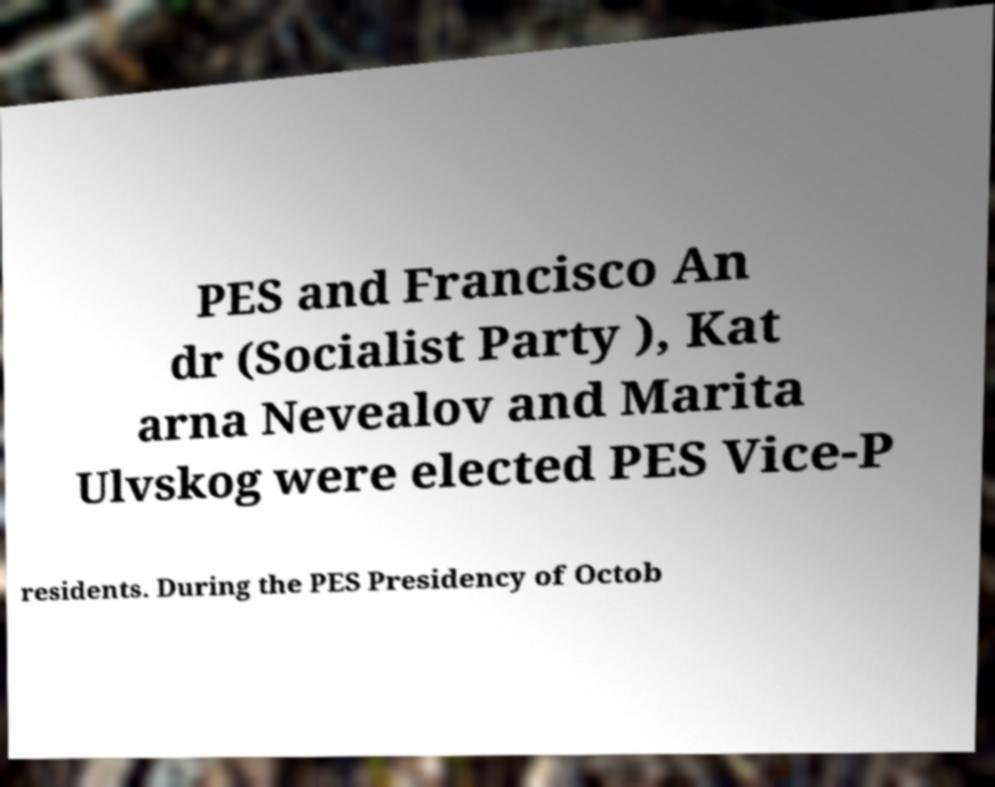Please identify and transcribe the text found in this image. PES and Francisco An dr (Socialist Party ), Kat arna Nevealov and Marita Ulvskog were elected PES Vice-P residents. During the PES Presidency of Octob 